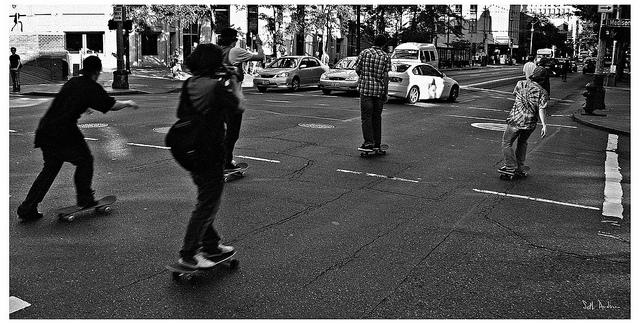What type of shirt is the man on the right wearing?

Choices:
A) plaid
B) tie dye
C) flannel
D) hippie special tie dye 